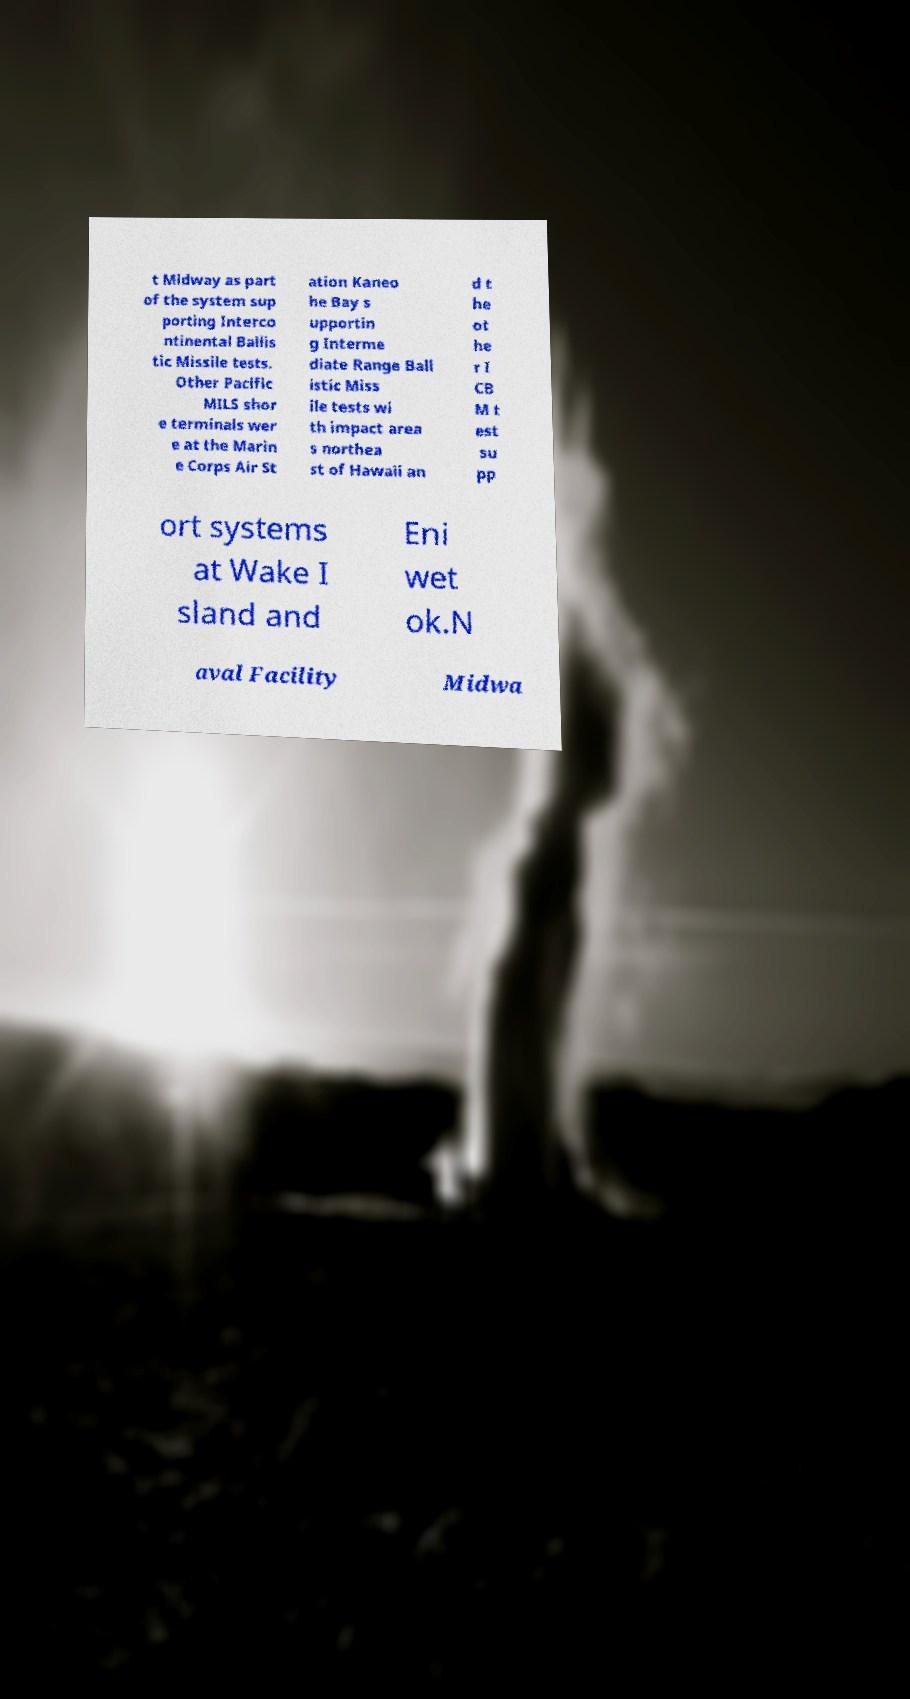Please read and relay the text visible in this image. What does it say? t Midway as part of the system sup porting Interco ntinental Ballis tic Missile tests. Other Pacific MILS shor e terminals wer e at the Marin e Corps Air St ation Kaneo he Bay s upportin g Interme diate Range Ball istic Miss ile tests wi th impact area s northea st of Hawaii an d t he ot he r I CB M t est su pp ort systems at Wake I sland and Eni wet ok.N aval Facility Midwa 